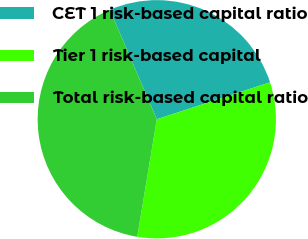<chart> <loc_0><loc_0><loc_500><loc_500><pie_chart><fcel>CET 1 risk-based capital ratio<fcel>Tier 1 risk-based capital<fcel>Total risk-based capital ratio<nl><fcel>26.43%<fcel>32.64%<fcel>40.93%<nl></chart> 